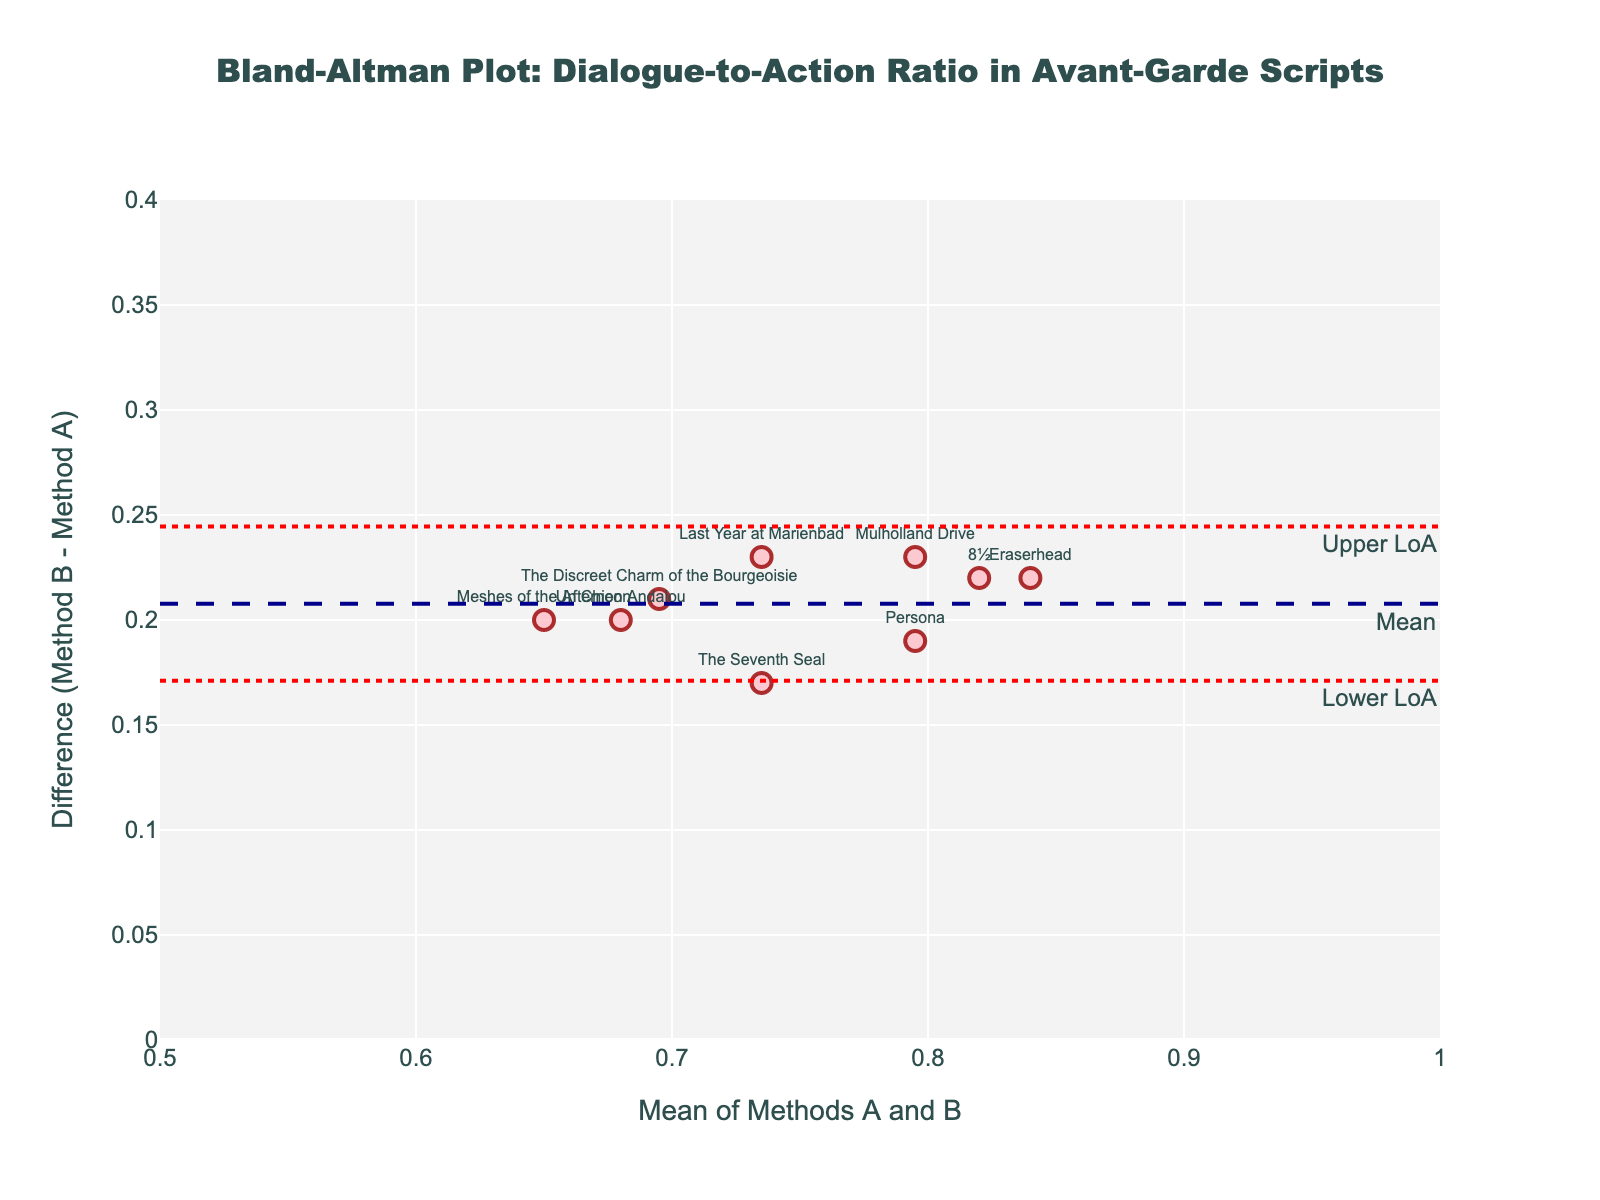Which script has the highest dialogue-to-action ratio for unsuccessful scripts? Look at the scatter points in the plot, find the highest y-coordinate value, and refer to its hover text or label. This corresponds to the highest dialogue-to-action ratio for unsuccessful scripts.
Answer: "8½" What is the mean difference in dialogue-to-action ratio between successful and unsuccessful scripts? The mean difference is represented by the dashed line in the plot and is often annotated. Look for the line labeled "Mean" and its y-coordinate.
Answer: Approximately 0.23 Are there any scripts falling outside the limits of agreement? Check the plot for data points positioned above the "Upper LoA" line or below the "Lower LoA" line. No points should cross these dotted lines if they are within the limits of agreement.
Answer: No What's the overall trend shown by the difference between successful and unsuccessful scripts as the mean dialogue-to-action ratio increases? Observe the placement of the scatter points relative to the mean difference line. If points generally lie above the line, unsuccessful scripts have a higher ratio, and if below, successful scripts have a higher ratio.
Answer: Unsuccessful scripts tend to have a higher ratio Which script has the lowest difference in dialogue-to-action ratio between successful and unsuccessful scripts? Look for the data point closest to the mean difference line on the plot, or check hover texts for the smallest y-difference value.
Answer: "The Seventh Seal" Is there a script where the dialogue-to-action ratio is the same for both successful and unsuccessful versions? In a Bland–Altman plot, if a script has the same ratio, its y-coordinate (difference) would be zero. Look for any point on the y=0 line.
Answer: No Between "Eraserhead" and "Persona", which has the larger difference in dialogue-to-action ratio? Find the y-coordinates of the points corresponding to "Eraserhead" and "Persona" and compare which is higher.
Answer: "Eraserhead" In general, are unsuccessful scripts characterized by more dialogues compared to successful scripts? Based on the plot, if most points lie above the mean difference line, then unsuccessful scripts generally have more dialogue ratio.
Answer: Yes What are the limits of agreement for this dataset? Limits of agreement are typically shown as two dotted lines on the plot with annotations. Identify the y-coordinates of these lines from the plot.
Answer: Approximately (0.09, 0.37) What does it mean if a script's point falls within the limits of agreement? Points within the limits of agreement indicate the difference in dialogue-to-action ratios between successful and unsuccessful scripts are within the expected variation.
Answer: Expected variation 